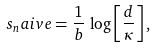Convert formula to latex. <formula><loc_0><loc_0><loc_500><loc_500>s _ { n } a i v e = \frac { 1 } { b } \, \log \left [ \frac { d } { \kappa } \right ] ,</formula> 